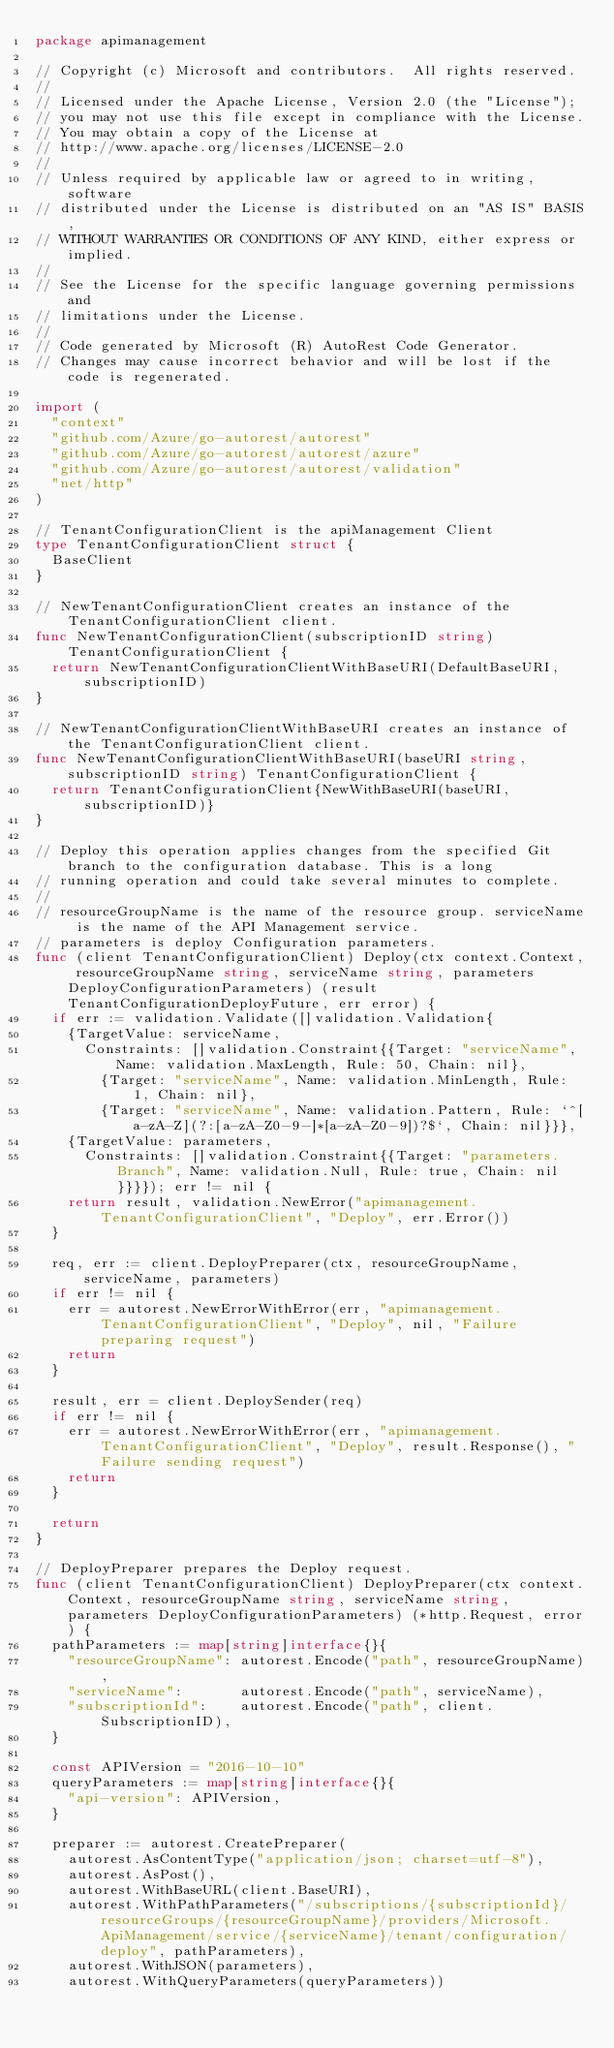<code> <loc_0><loc_0><loc_500><loc_500><_Go_>package apimanagement

// Copyright (c) Microsoft and contributors.  All rights reserved.
//
// Licensed under the Apache License, Version 2.0 (the "License");
// you may not use this file except in compliance with the License.
// You may obtain a copy of the License at
// http://www.apache.org/licenses/LICENSE-2.0
//
// Unless required by applicable law or agreed to in writing, software
// distributed under the License is distributed on an "AS IS" BASIS,
// WITHOUT WARRANTIES OR CONDITIONS OF ANY KIND, either express or implied.
//
// See the License for the specific language governing permissions and
// limitations under the License.
//
// Code generated by Microsoft (R) AutoRest Code Generator.
// Changes may cause incorrect behavior and will be lost if the code is regenerated.

import (
	"context"
	"github.com/Azure/go-autorest/autorest"
	"github.com/Azure/go-autorest/autorest/azure"
	"github.com/Azure/go-autorest/autorest/validation"
	"net/http"
)

// TenantConfigurationClient is the apiManagement Client
type TenantConfigurationClient struct {
	BaseClient
}

// NewTenantConfigurationClient creates an instance of the TenantConfigurationClient client.
func NewTenantConfigurationClient(subscriptionID string) TenantConfigurationClient {
	return NewTenantConfigurationClientWithBaseURI(DefaultBaseURI, subscriptionID)
}

// NewTenantConfigurationClientWithBaseURI creates an instance of the TenantConfigurationClient client.
func NewTenantConfigurationClientWithBaseURI(baseURI string, subscriptionID string) TenantConfigurationClient {
	return TenantConfigurationClient{NewWithBaseURI(baseURI, subscriptionID)}
}

// Deploy this operation applies changes from the specified Git branch to the configuration database. This is a long
// running operation and could take several minutes to complete.
//
// resourceGroupName is the name of the resource group. serviceName is the name of the API Management service.
// parameters is deploy Configuration parameters.
func (client TenantConfigurationClient) Deploy(ctx context.Context, resourceGroupName string, serviceName string, parameters DeployConfigurationParameters) (result TenantConfigurationDeployFuture, err error) {
	if err := validation.Validate([]validation.Validation{
		{TargetValue: serviceName,
			Constraints: []validation.Constraint{{Target: "serviceName", Name: validation.MaxLength, Rule: 50, Chain: nil},
				{Target: "serviceName", Name: validation.MinLength, Rule: 1, Chain: nil},
				{Target: "serviceName", Name: validation.Pattern, Rule: `^[a-zA-Z](?:[a-zA-Z0-9-]*[a-zA-Z0-9])?$`, Chain: nil}}},
		{TargetValue: parameters,
			Constraints: []validation.Constraint{{Target: "parameters.Branch", Name: validation.Null, Rule: true, Chain: nil}}}}); err != nil {
		return result, validation.NewError("apimanagement.TenantConfigurationClient", "Deploy", err.Error())
	}

	req, err := client.DeployPreparer(ctx, resourceGroupName, serviceName, parameters)
	if err != nil {
		err = autorest.NewErrorWithError(err, "apimanagement.TenantConfigurationClient", "Deploy", nil, "Failure preparing request")
		return
	}

	result, err = client.DeploySender(req)
	if err != nil {
		err = autorest.NewErrorWithError(err, "apimanagement.TenantConfigurationClient", "Deploy", result.Response(), "Failure sending request")
		return
	}

	return
}

// DeployPreparer prepares the Deploy request.
func (client TenantConfigurationClient) DeployPreparer(ctx context.Context, resourceGroupName string, serviceName string, parameters DeployConfigurationParameters) (*http.Request, error) {
	pathParameters := map[string]interface{}{
		"resourceGroupName": autorest.Encode("path", resourceGroupName),
		"serviceName":       autorest.Encode("path", serviceName),
		"subscriptionId":    autorest.Encode("path", client.SubscriptionID),
	}

	const APIVersion = "2016-10-10"
	queryParameters := map[string]interface{}{
		"api-version": APIVersion,
	}

	preparer := autorest.CreatePreparer(
		autorest.AsContentType("application/json; charset=utf-8"),
		autorest.AsPost(),
		autorest.WithBaseURL(client.BaseURI),
		autorest.WithPathParameters("/subscriptions/{subscriptionId}/resourceGroups/{resourceGroupName}/providers/Microsoft.ApiManagement/service/{serviceName}/tenant/configuration/deploy", pathParameters),
		autorest.WithJSON(parameters),
		autorest.WithQueryParameters(queryParameters))</code> 